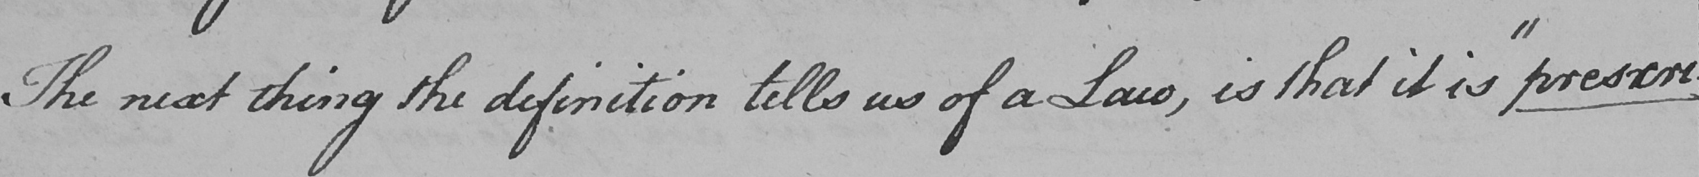What does this handwritten line say? The next thing the definition tells us of a Law , is that it is  " prescri- 